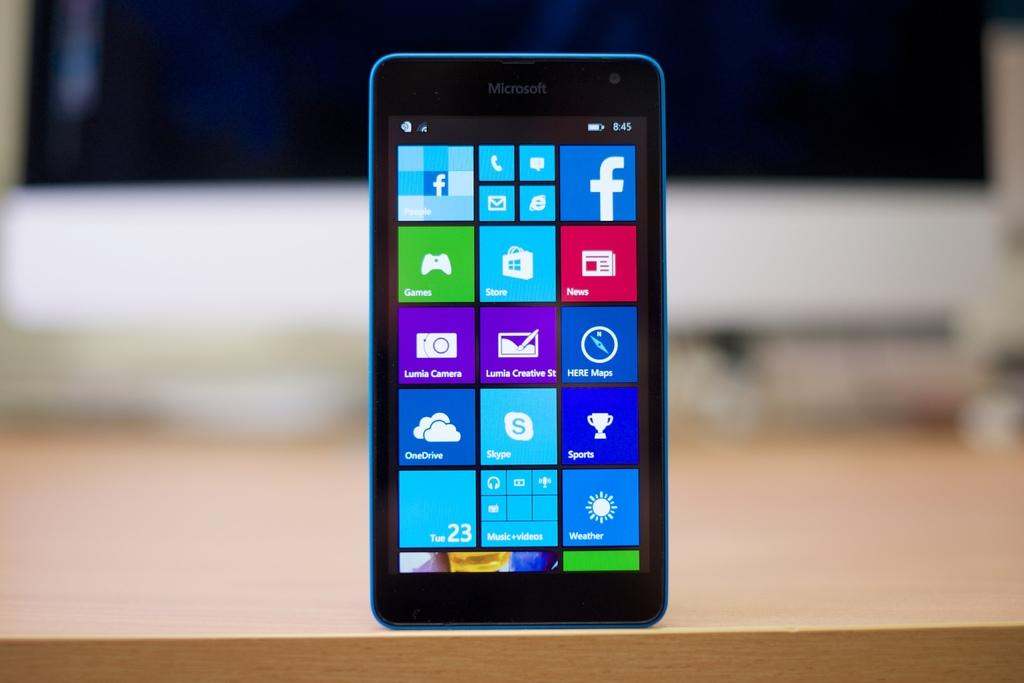<image>
Relay a brief, clear account of the picture shown. The cellphone standing upright displays it's Tue 23. 